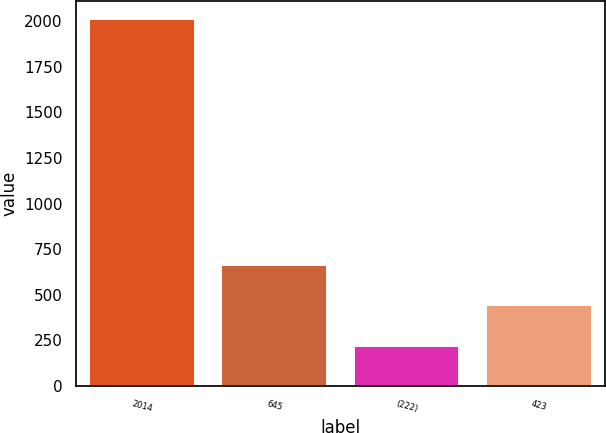Convert chart. <chart><loc_0><loc_0><loc_500><loc_500><bar_chart><fcel>2014<fcel>645<fcel>(222)<fcel>423<nl><fcel>2012<fcel>661<fcel>219<fcel>442<nl></chart> 